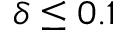Convert formula to latex. <formula><loc_0><loc_0><loc_500><loc_500>\delta \leq 0 . 1</formula> 